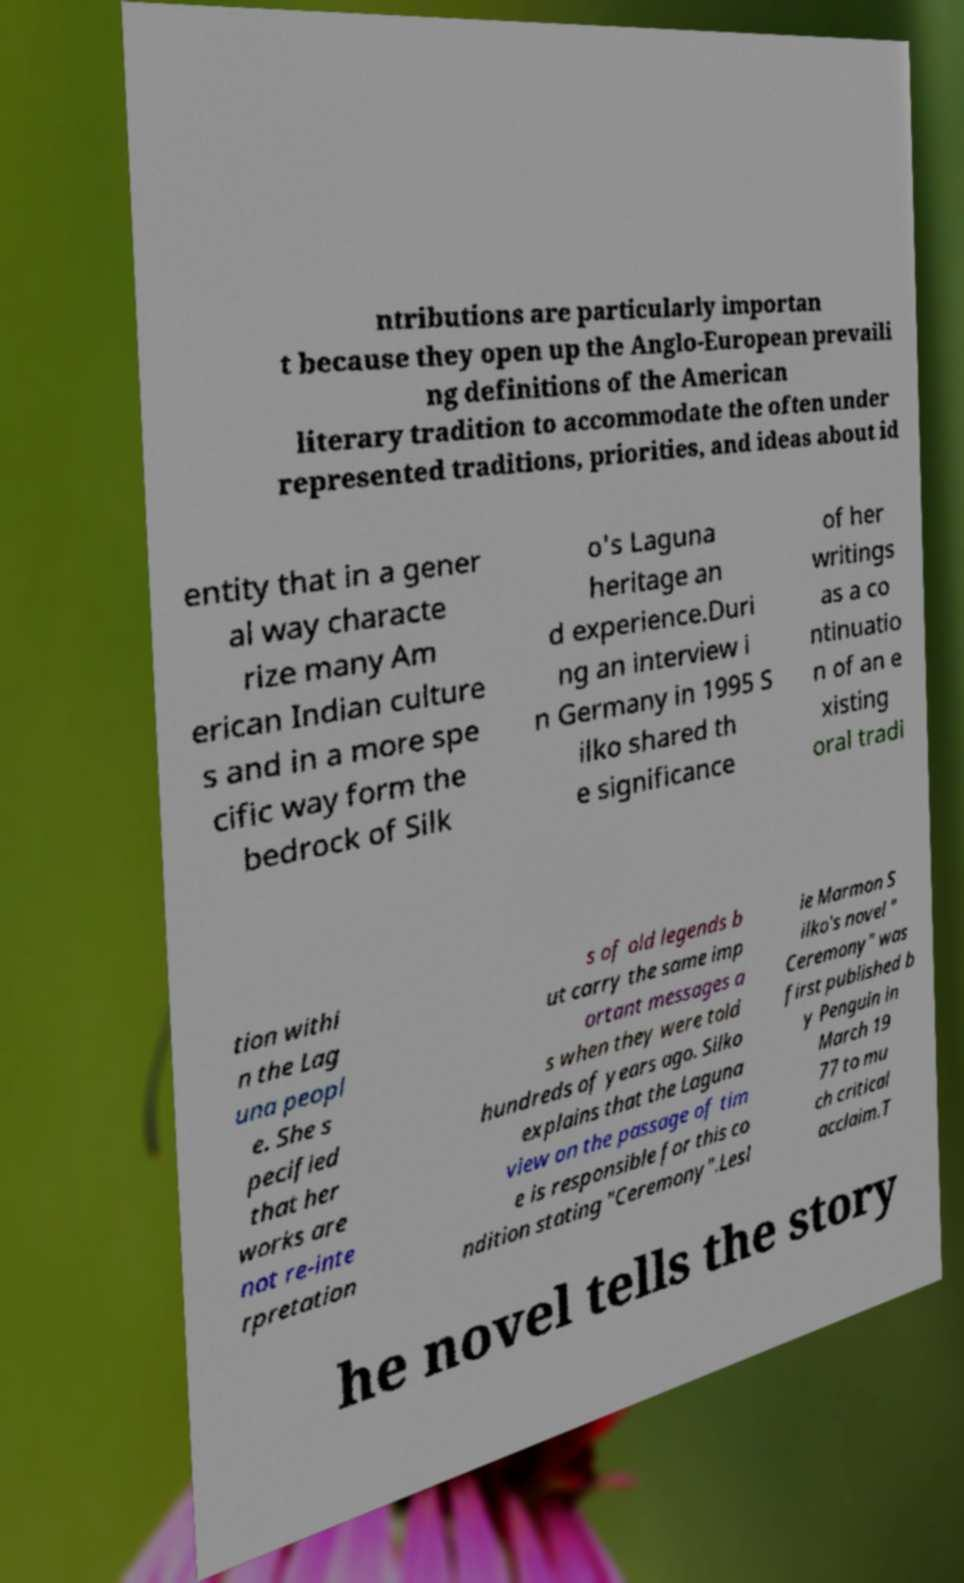For documentation purposes, I need the text within this image transcribed. Could you provide that? ntributions are particularly importan t because they open up the Anglo-European prevaili ng definitions of the American literary tradition to accommodate the often under represented traditions, priorities, and ideas about id entity that in a gener al way characte rize many Am erican Indian culture s and in a more spe cific way form the bedrock of Silk o's Laguna heritage an d experience.Duri ng an interview i n Germany in 1995 S ilko shared th e significance of her writings as a co ntinuatio n of an e xisting oral tradi tion withi n the Lag una peopl e. She s pecified that her works are not re-inte rpretation s of old legends b ut carry the same imp ortant messages a s when they were told hundreds of years ago. Silko explains that the Laguna view on the passage of tim e is responsible for this co ndition stating "Ceremony".Lesl ie Marmon S ilko's novel " Ceremony" was first published b y Penguin in March 19 77 to mu ch critical acclaim.T he novel tells the story 